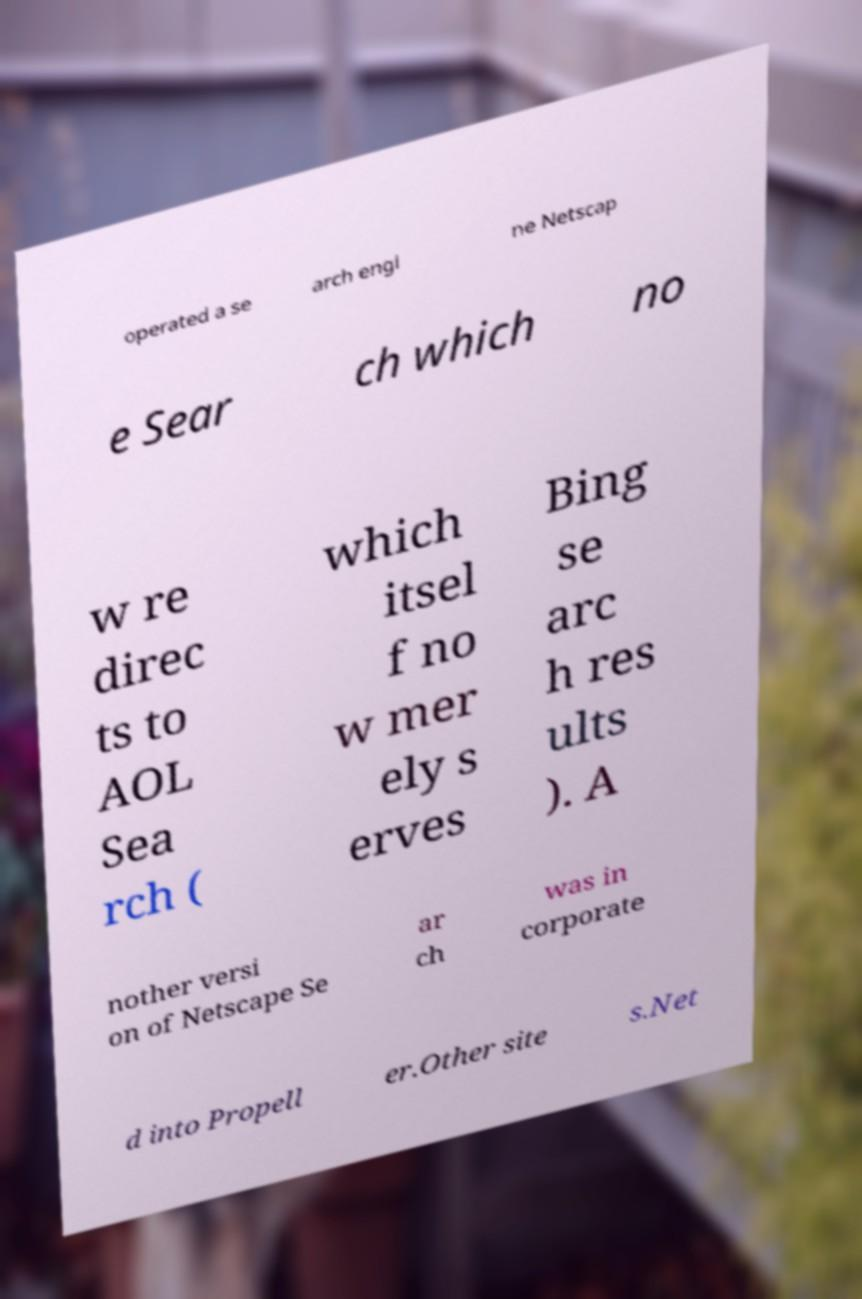Please read and relay the text visible in this image. What does it say? operated a se arch engi ne Netscap e Sear ch which no w re direc ts to AOL Sea rch ( which itsel f no w mer ely s erves Bing se arc h res ults ). A nother versi on of Netscape Se ar ch was in corporate d into Propell er.Other site s.Net 